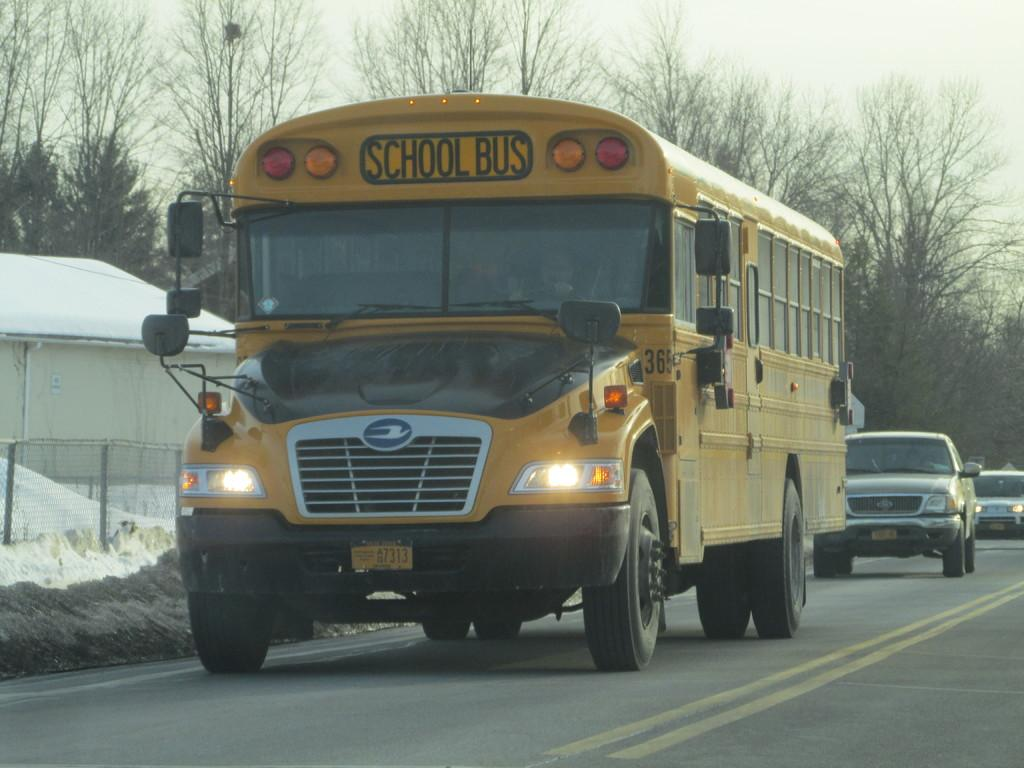What can be seen on the road in the image? There are vehicles on the road in the image. What type of natural elements are visible in the image? There are trees visible in the image. What is the purpose of the barrier in the image? There is a fence in the image, which serves as a barrier or boundary. What is visible above the ground in the image? The sky is visible in the image. Where is the hydrant located in the image? There is no hydrant present in the image. Is there a volcano visible in the image? No, there is no volcano present in the image. 